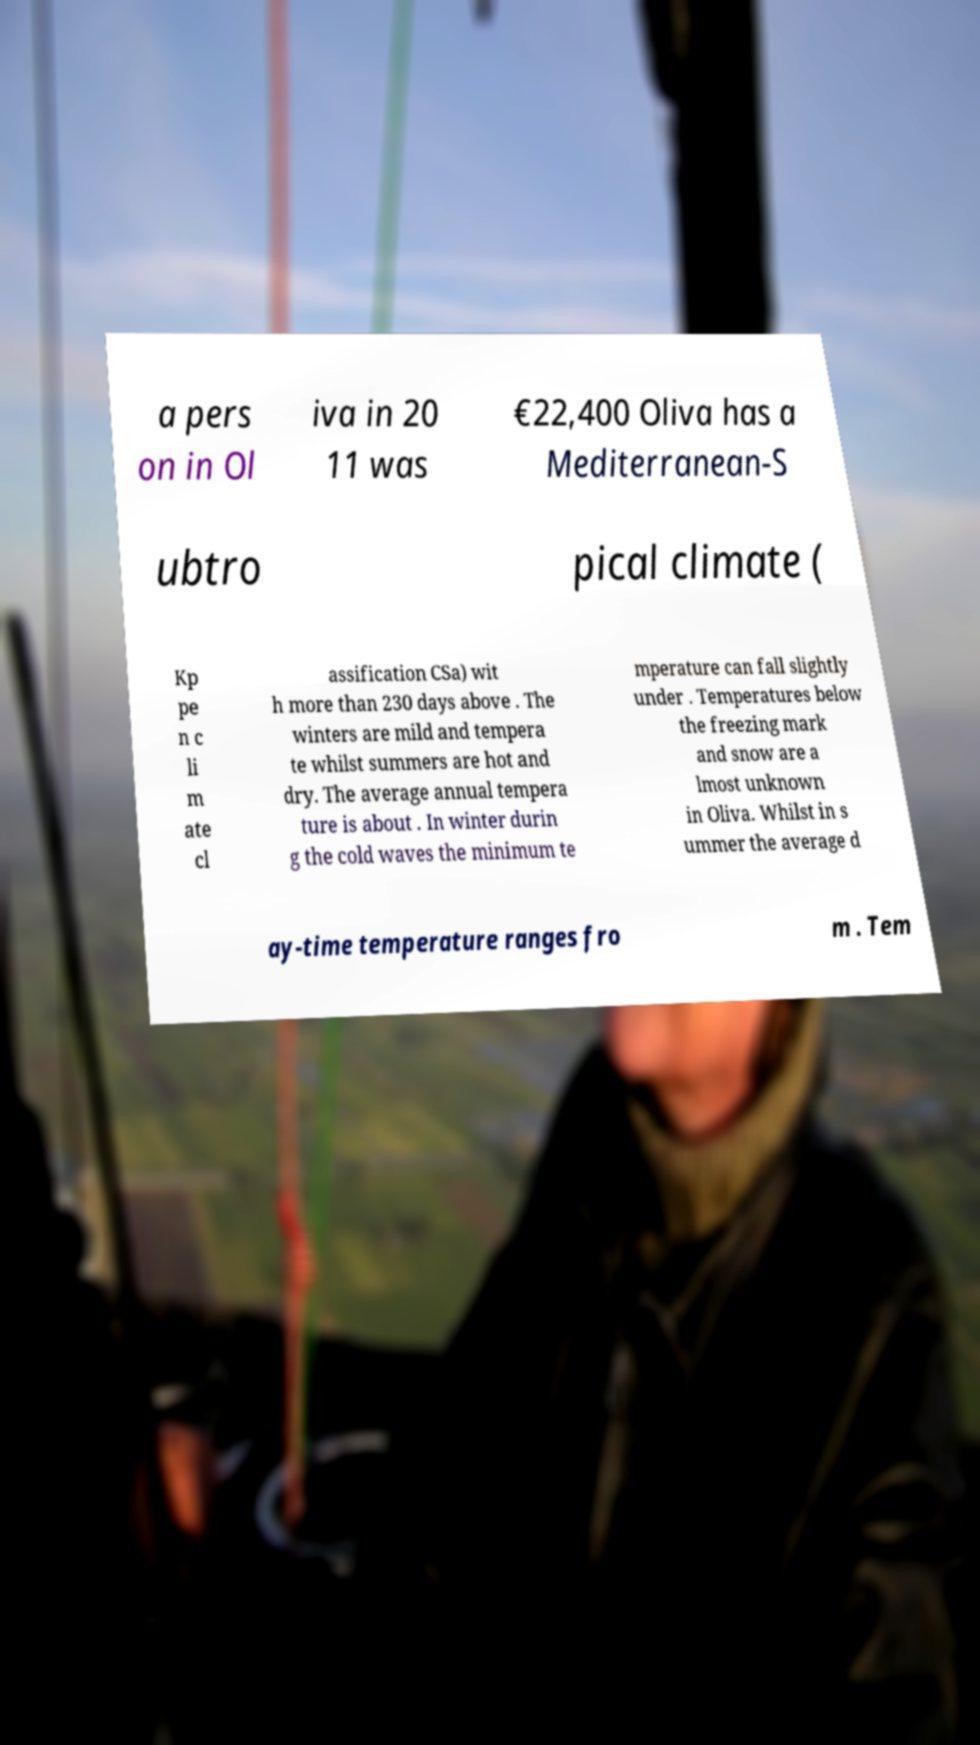For documentation purposes, I need the text within this image transcribed. Could you provide that? a pers on in Ol iva in 20 11 was €22,400 Oliva has a Mediterranean-S ubtro pical climate ( Kp pe n c li m ate cl assification CSa) wit h more than 230 days above . The winters are mild and tempera te whilst summers are hot and dry. The average annual tempera ture is about . In winter durin g the cold waves the minimum te mperature can fall slightly under . Temperatures below the freezing mark and snow are a lmost unknown in Oliva. Whilst in s ummer the average d ay-time temperature ranges fro m . Tem 